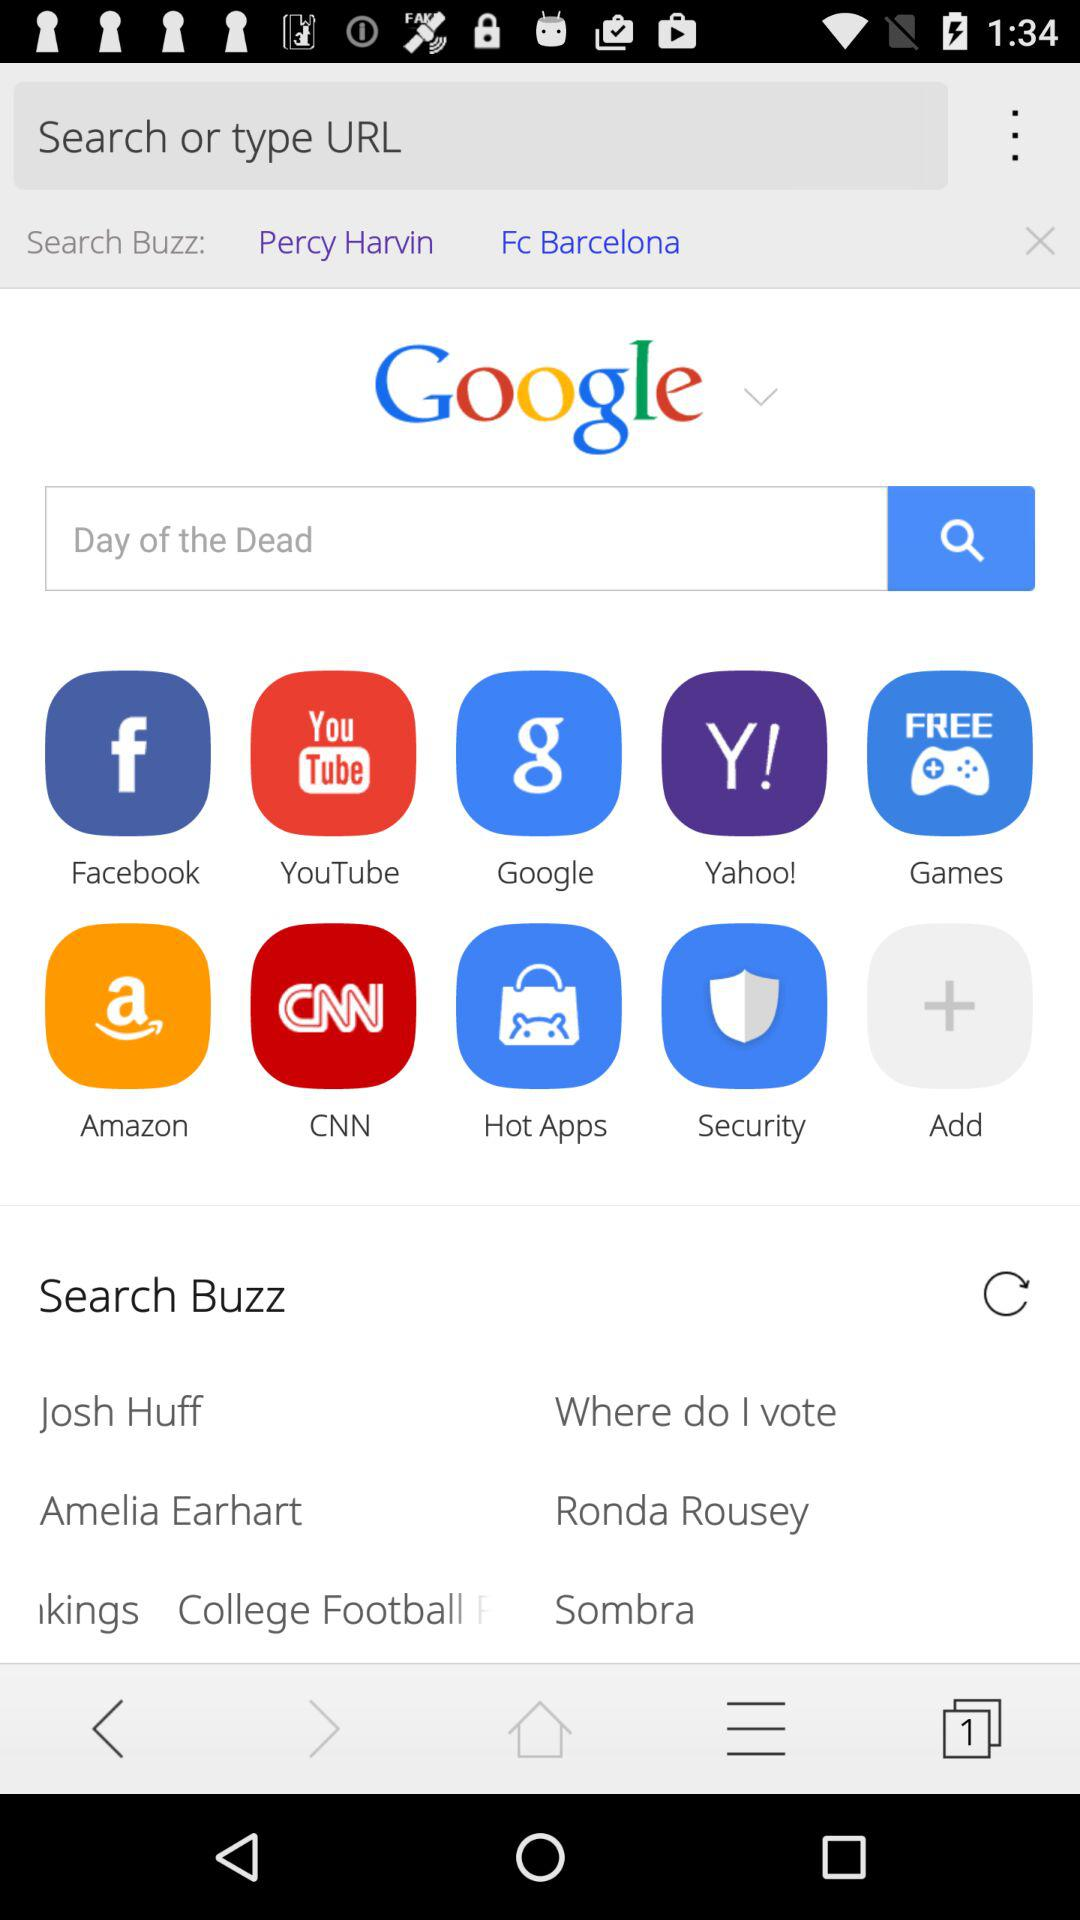What is the input text entered into the search bar? The entered text is "Day of the Dead". 